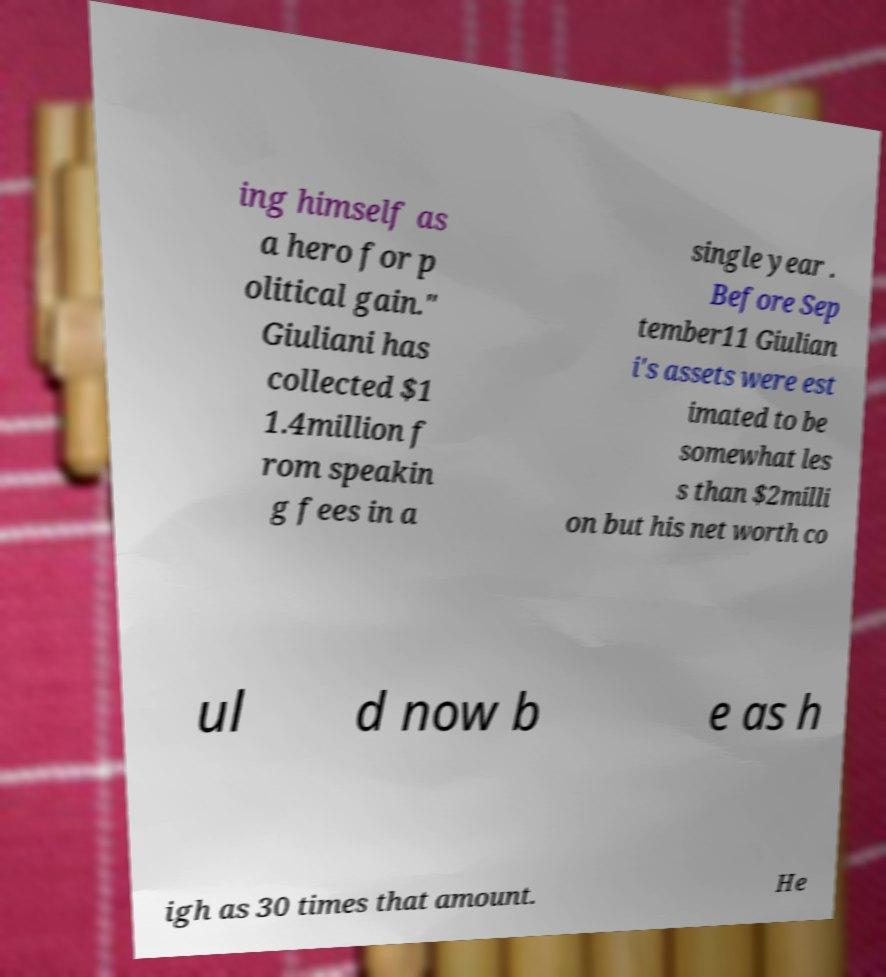Could you extract and type out the text from this image? ing himself as a hero for p olitical gain." Giuliani has collected $1 1.4million f rom speakin g fees in a single year . Before Sep tember11 Giulian i's assets were est imated to be somewhat les s than $2milli on but his net worth co ul d now b e as h igh as 30 times that amount. He 